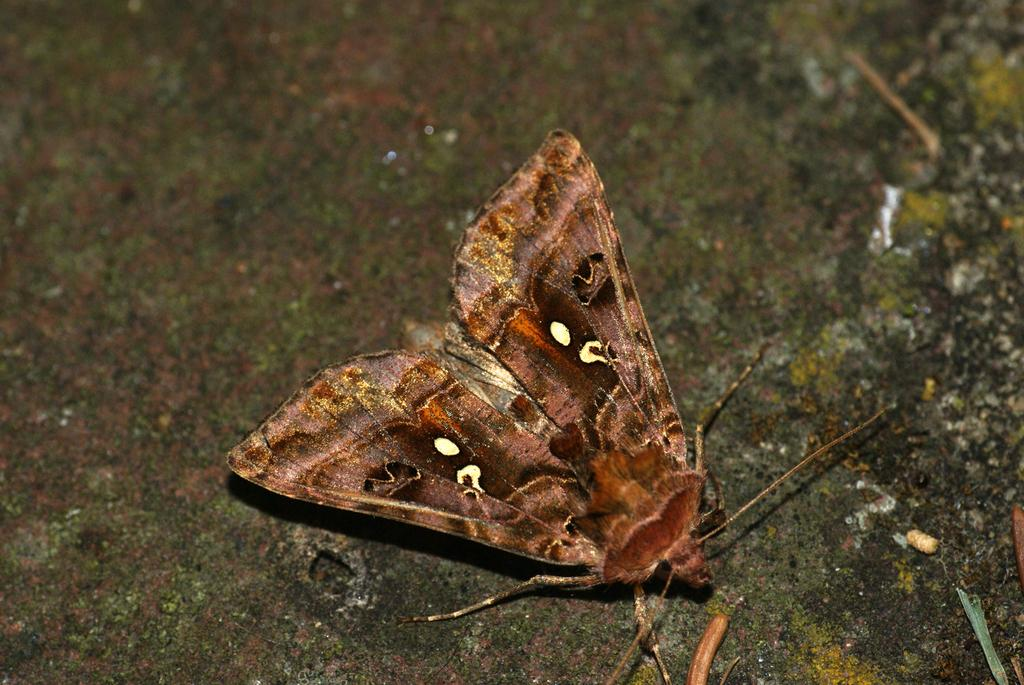What type of animal can be seen in the image? There is a butterfly in the image. How many train tracks are visible in the image? There are no train tracks present in the image; it features a butterfly. What type of wing is attached to the butterfly in the image? The butterfly in the image has wings, but we cannot determine the specific type of wing from the image alone. 